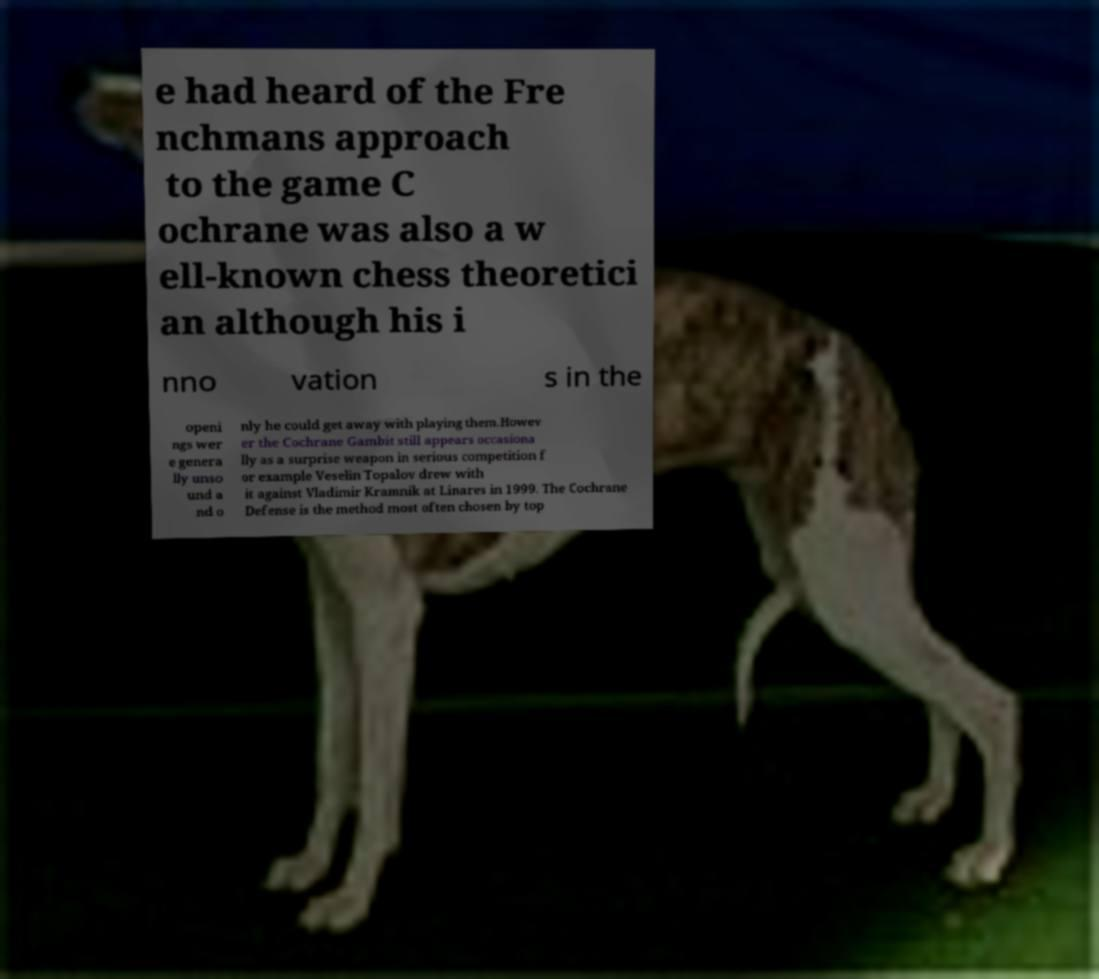Please read and relay the text visible in this image. What does it say? e had heard of the Fre nchmans approach to the game C ochrane was also a w ell-known chess theoretici an although his i nno vation s in the openi ngs wer e genera lly unso und a nd o nly he could get away with playing them.Howev er the Cochrane Gambit still appears occasiona lly as a surprise weapon in serious competition f or example Veselin Topalov drew with it against Vladimir Kramnik at Linares in 1999. The Cochrane Defense is the method most often chosen by top 